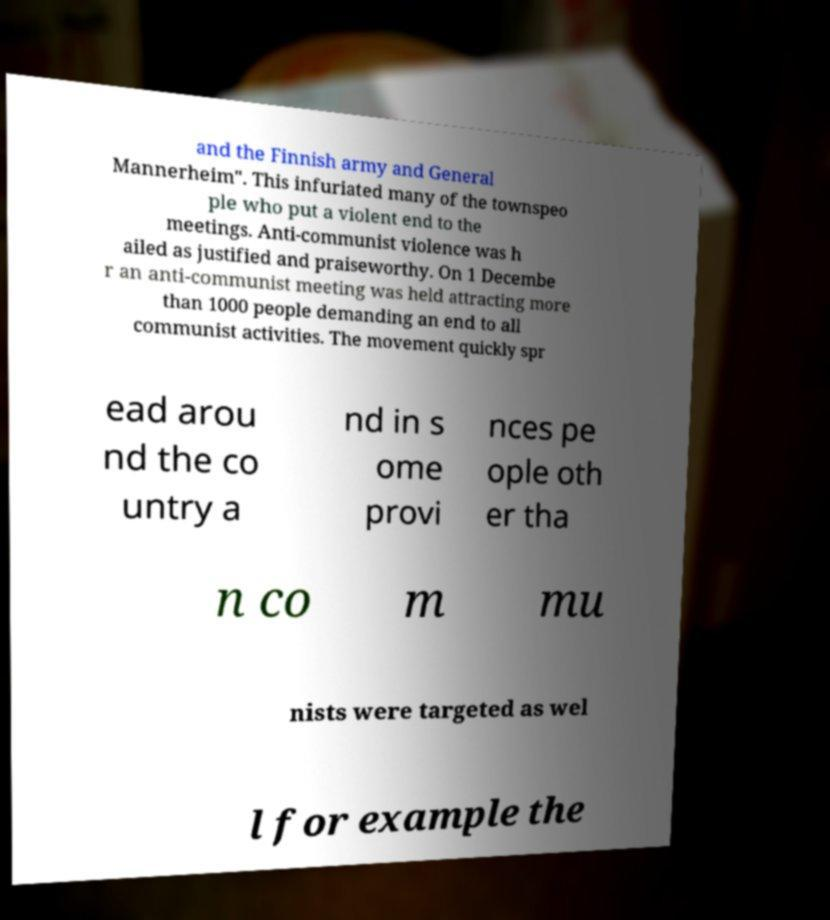Can you read and provide the text displayed in the image?This photo seems to have some interesting text. Can you extract and type it out for me? and the Finnish army and General Mannerheim". This infuriated many of the townspeo ple who put a violent end to the meetings. Anti-communist violence was h ailed as justified and praiseworthy. On 1 Decembe r an anti-communist meeting was held attracting more than 1000 people demanding an end to all communist activities. The movement quickly spr ead arou nd the co untry a nd in s ome provi nces pe ople oth er tha n co m mu nists were targeted as wel l for example the 